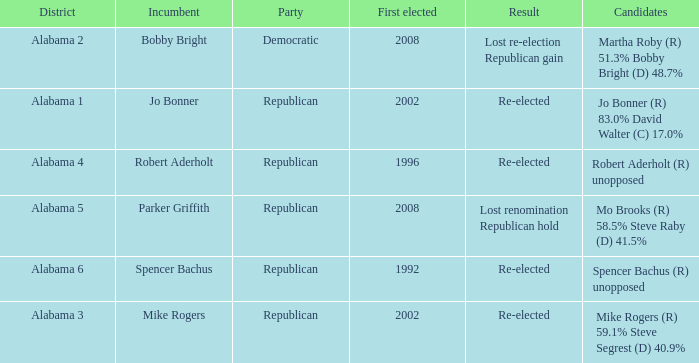Name the incumbent for lost renomination republican hold Parker Griffith. 